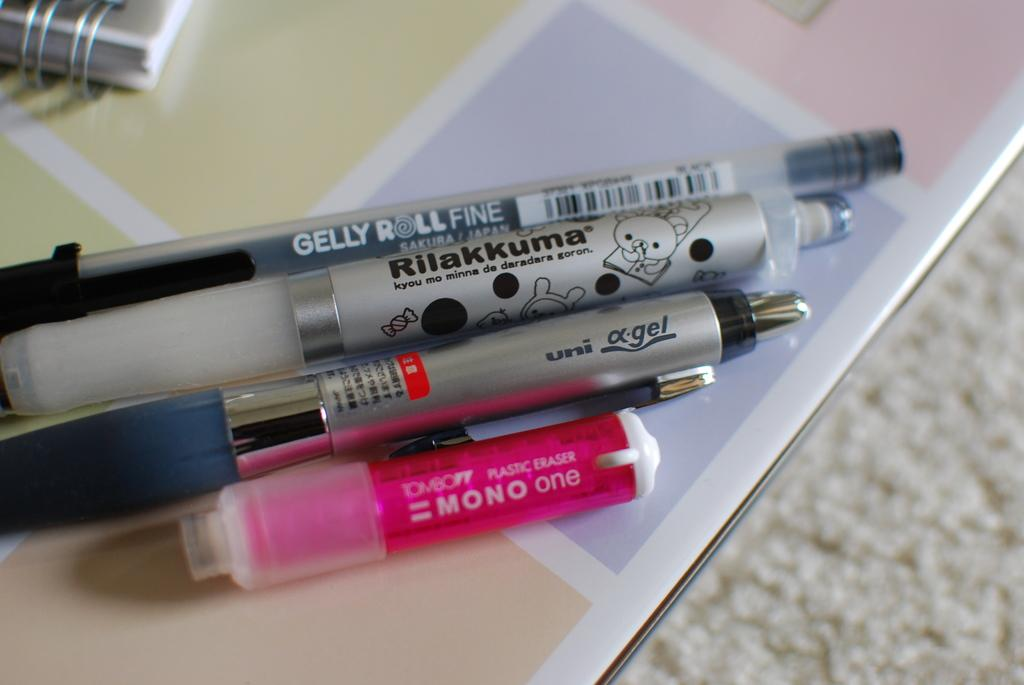What is placed on the table in the image? There is a book on the table. What else can be seen on the table? There are pens, a pink object, and a small white object on the table. Can you describe the pink object on the table? The pink object on the table is not clearly identifiable from the image. What is the white object on the floor that looks like a carpet? There is a white object on the floor that looks like a carpet. What type of thrill can be heard coming from the bells in the image? There are no bells present in the image, so it's not possible to determine what type of thrill might be heard. 